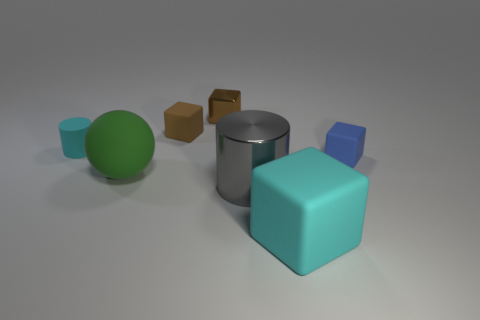What is the shape of the shiny object in front of the cyan cylinder?
Your answer should be compact. Cylinder. What number of other large things are the same shape as the blue object?
Provide a short and direct response. 1. Do the tiny matte cylinder that is left of the big cylinder and the tiny block that is in front of the tiny cyan cylinder have the same color?
Your answer should be compact. No. How many objects are tiny brown metallic blocks or cylinders?
Provide a short and direct response. 3. How many tiny red blocks are made of the same material as the sphere?
Provide a short and direct response. 0. Are there fewer gray cylinders than large red matte blocks?
Provide a short and direct response. No. Are the tiny object that is in front of the cyan cylinder and the small cyan object made of the same material?
Offer a very short reply. Yes. What number of cylinders are small cyan shiny things or big gray metal objects?
Make the answer very short. 1. There is a tiny matte object that is both to the left of the small blue matte thing and to the right of the tiny matte cylinder; what is its shape?
Provide a succinct answer. Cube. There is a tiny matte object right of the cylinder that is in front of the large rubber thing that is left of the shiny cylinder; what is its color?
Give a very brief answer. Blue. 